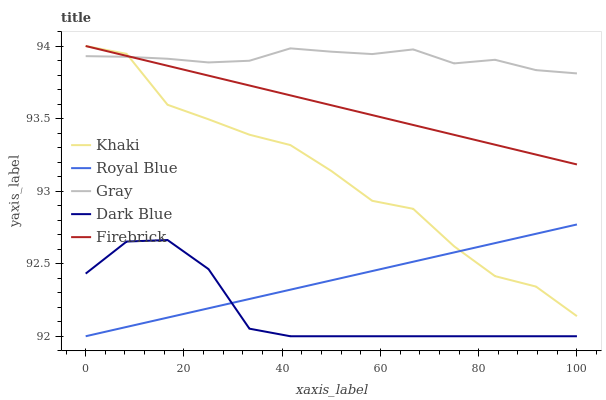Does Dark Blue have the minimum area under the curve?
Answer yes or no. Yes. Does Gray have the maximum area under the curve?
Answer yes or no. Yes. Does Firebrick have the minimum area under the curve?
Answer yes or no. No. Does Firebrick have the maximum area under the curve?
Answer yes or no. No. Is Royal Blue the smoothest?
Answer yes or no. Yes. Is Khaki the roughest?
Answer yes or no. Yes. Is Firebrick the smoothest?
Answer yes or no. No. Is Firebrick the roughest?
Answer yes or no. No. Does Royal Blue have the lowest value?
Answer yes or no. Yes. Does Firebrick have the lowest value?
Answer yes or no. No. Does Khaki have the highest value?
Answer yes or no. Yes. Does Dark Blue have the highest value?
Answer yes or no. No. Is Royal Blue less than Gray?
Answer yes or no. Yes. Is Gray greater than Dark Blue?
Answer yes or no. Yes. Does Firebrick intersect Khaki?
Answer yes or no. Yes. Is Firebrick less than Khaki?
Answer yes or no. No. Is Firebrick greater than Khaki?
Answer yes or no. No. Does Royal Blue intersect Gray?
Answer yes or no. No. 